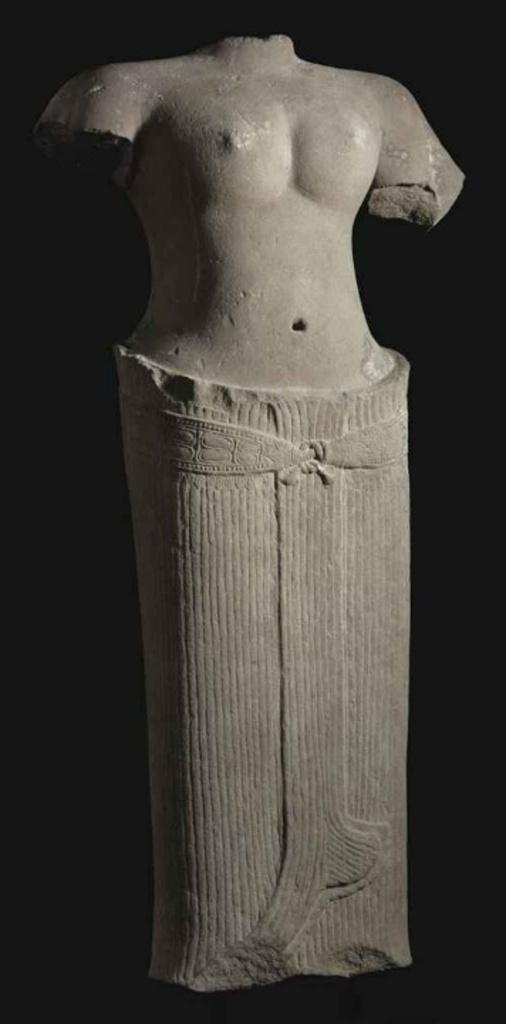What is the main subject of the image? There is a statue in the image. What can be observed about the background of the image? The background of the image is dark. What type of animal can be seen on the moon in the image? There is no animal or moon present in the image; it features a statue with a dark background. 